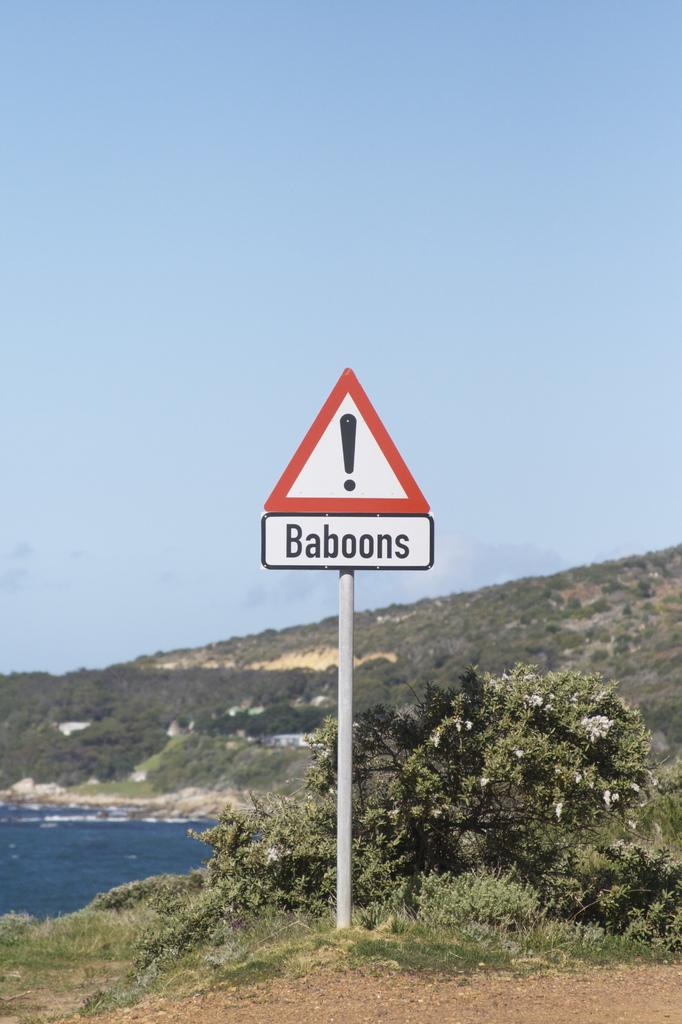<image>
Provide a brief description of the given image. A hazard sign is outside that warns of baboons. 